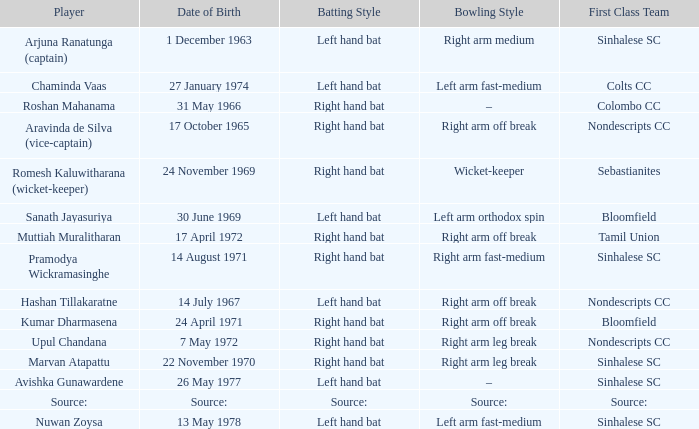When was avishka gunawardene born? 26 May 1977. 